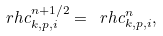<formula> <loc_0><loc_0><loc_500><loc_500>\ r h c ^ { n + 1 / 2 } _ { k , p , i } = \ r h c ^ { n } _ { k , p , i } ,</formula> 